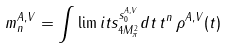Convert formula to latex. <formula><loc_0><loc_0><loc_500><loc_500>m _ { n } ^ { A , V } = \int \lim i t s _ { 4 M ^ { 2 } _ { \pi } } ^ { s _ { 0 } ^ { A , V } } d t \, t ^ { n } \, \rho ^ { A , V } ( t )</formula> 